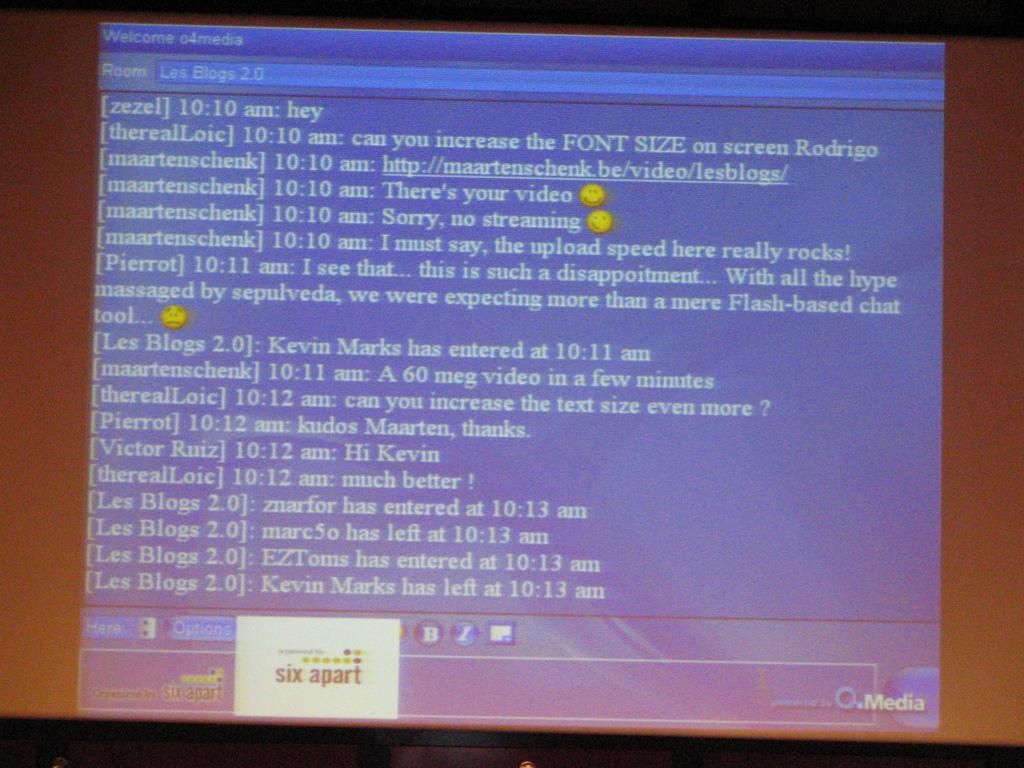<image>
Create a compact narrative representing the image presented. Screenshot of a monitor with a chat transcript on it starting with a message by zezel saying "hey" 